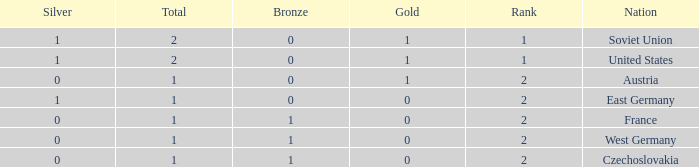What is the highest rank of Austria, which had less than 0 silvers? None. 